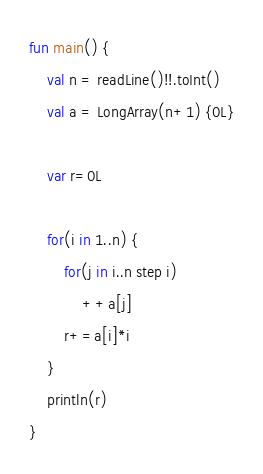Convert code to text. <code><loc_0><loc_0><loc_500><loc_500><_Kotlin_>fun main() {
	val n = readLine()!!.toInt()
	val a = LongArray(n+1) {0L}

	var r=0L

	for(i in 1..n) {
		for(j in i..n step i)
			++a[j]
		r+=a[i]*i
	}
	println(r)
}
</code> 